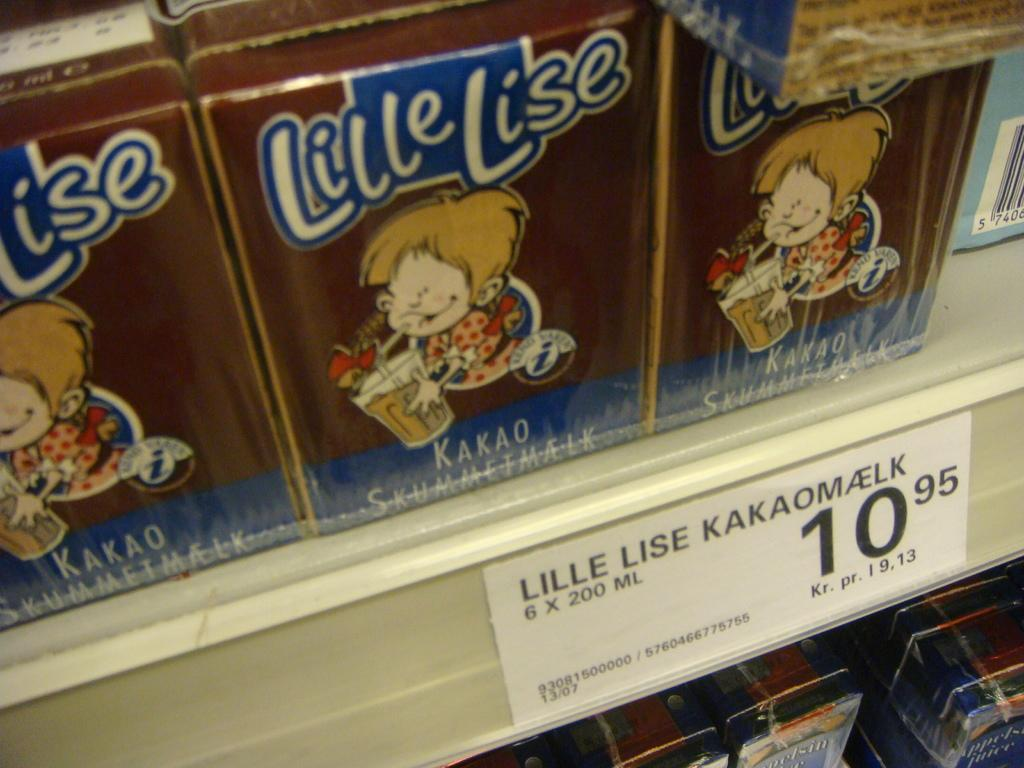What can be seen arranged in the rack in the image? There are food items arranged in a rack in the image. What additional information is provided in the image? There is a label with text on it in the image. How many pencils can be seen in the image? There are no pencils present in the image. What type of cattle is visible in the image? There is no cattle present in the image. 